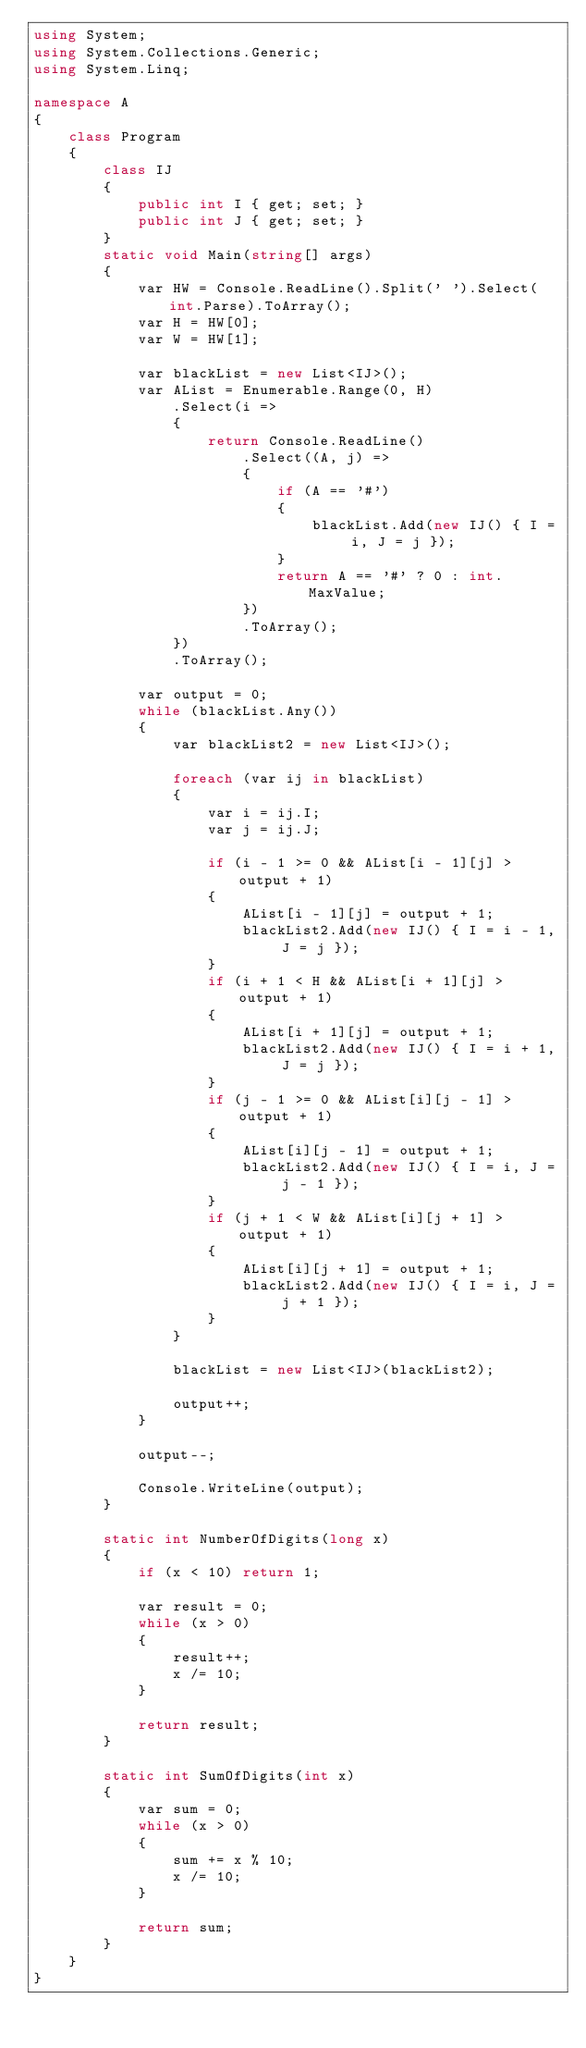<code> <loc_0><loc_0><loc_500><loc_500><_C#_>using System;
using System.Collections.Generic;
using System.Linq;

namespace A
{
    class Program
    {
        class IJ
        {
            public int I { get; set; }
            public int J { get; set; }
        }
        static void Main(string[] args)
        {
            var HW = Console.ReadLine().Split(' ').Select(int.Parse).ToArray();
            var H = HW[0];
            var W = HW[1];

            var blackList = new List<IJ>();
            var AList = Enumerable.Range(0, H)
                .Select(i =>
                {
                    return Console.ReadLine()
                        .Select((A, j) =>
                        {
                            if (A == '#')
                            {
                                blackList.Add(new IJ() { I = i, J = j });
                            }
                            return A == '#' ? 0 : int.MaxValue;
                        })
                        .ToArray();
                })
                .ToArray();

            var output = 0;
            while (blackList.Any())
            {
                var blackList2 = new List<IJ>();

                foreach (var ij in blackList)
                {
                    var i = ij.I;
                    var j = ij.J;

                    if (i - 1 >= 0 && AList[i - 1][j] > output + 1)
                    {
                        AList[i - 1][j] = output + 1;
                        blackList2.Add(new IJ() { I = i - 1, J = j });
                    }
                    if (i + 1 < H && AList[i + 1][j] > output + 1)
                    {
                        AList[i + 1][j] = output + 1;
                        blackList2.Add(new IJ() { I = i + 1, J = j });
                    }
                    if (j - 1 >= 0 && AList[i][j - 1] > output + 1)
                    {
                        AList[i][j - 1] = output + 1;
                        blackList2.Add(new IJ() { I = i, J = j - 1 });
                    }
                    if (j + 1 < W && AList[i][j + 1] > output + 1)
                    {
                        AList[i][j + 1] = output + 1;
                        blackList2.Add(new IJ() { I = i, J = j + 1 });
                    }
                }

                blackList = new List<IJ>(blackList2);

                output++;
            }

            output--;

            Console.WriteLine(output);
        }

        static int NumberOfDigits(long x)
        {
            if (x < 10) return 1;

            var result = 0;
            while (x > 0)
            {
                result++;
                x /= 10;
            }

            return result;
        }

        static int SumOfDigits(int x)
        {
            var sum = 0;
            while (x > 0)
            {
                sum += x % 10;
                x /= 10;
            }

            return sum;
        }
    }
}
</code> 